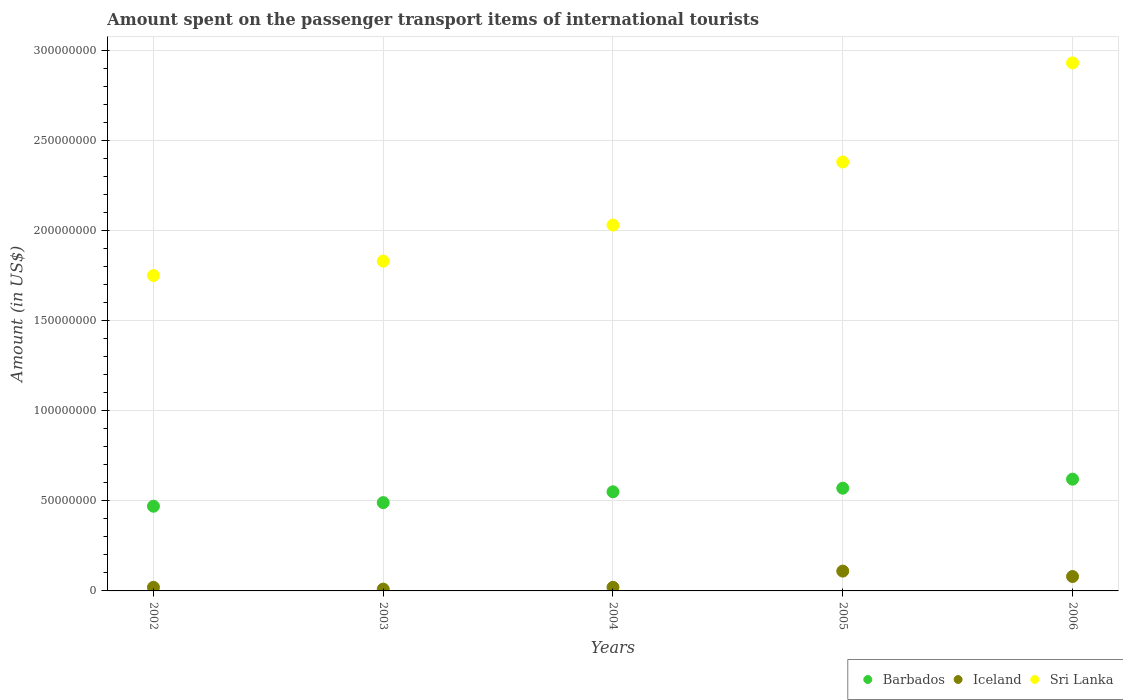How many different coloured dotlines are there?
Give a very brief answer. 3. Is the number of dotlines equal to the number of legend labels?
Your response must be concise. Yes. Across all years, what is the maximum amount spent on the passenger transport items of international tourists in Sri Lanka?
Give a very brief answer. 2.93e+08. Across all years, what is the minimum amount spent on the passenger transport items of international tourists in Barbados?
Keep it short and to the point. 4.70e+07. In which year was the amount spent on the passenger transport items of international tourists in Barbados maximum?
Ensure brevity in your answer.  2006. What is the total amount spent on the passenger transport items of international tourists in Barbados in the graph?
Your response must be concise. 2.70e+08. What is the difference between the amount spent on the passenger transport items of international tourists in Iceland in 2004 and that in 2005?
Give a very brief answer. -9.00e+06. What is the difference between the amount spent on the passenger transport items of international tourists in Sri Lanka in 2004 and the amount spent on the passenger transport items of international tourists in Barbados in 2002?
Your answer should be compact. 1.56e+08. What is the average amount spent on the passenger transport items of international tourists in Iceland per year?
Your response must be concise. 4.80e+06. In the year 2003, what is the difference between the amount spent on the passenger transport items of international tourists in Iceland and amount spent on the passenger transport items of international tourists in Sri Lanka?
Provide a short and direct response. -1.82e+08. In how many years, is the amount spent on the passenger transport items of international tourists in Iceland greater than 220000000 US$?
Provide a succinct answer. 0. What is the ratio of the amount spent on the passenger transport items of international tourists in Sri Lanka in 2002 to that in 2004?
Your response must be concise. 0.86. Is the difference between the amount spent on the passenger transport items of international tourists in Iceland in 2002 and 2006 greater than the difference between the amount spent on the passenger transport items of international tourists in Sri Lanka in 2002 and 2006?
Keep it short and to the point. Yes. What is the difference between the highest and the second highest amount spent on the passenger transport items of international tourists in Iceland?
Offer a very short reply. 3.00e+06. What is the difference between the highest and the lowest amount spent on the passenger transport items of international tourists in Iceland?
Give a very brief answer. 1.00e+07. Is the sum of the amount spent on the passenger transport items of international tourists in Barbados in 2005 and 2006 greater than the maximum amount spent on the passenger transport items of international tourists in Iceland across all years?
Provide a succinct answer. Yes. What is the difference between two consecutive major ticks on the Y-axis?
Provide a short and direct response. 5.00e+07. Does the graph contain any zero values?
Provide a short and direct response. No. Where does the legend appear in the graph?
Offer a very short reply. Bottom right. What is the title of the graph?
Ensure brevity in your answer.  Amount spent on the passenger transport items of international tourists. Does "Philippines" appear as one of the legend labels in the graph?
Give a very brief answer. No. What is the label or title of the Y-axis?
Offer a very short reply. Amount (in US$). What is the Amount (in US$) in Barbados in 2002?
Provide a short and direct response. 4.70e+07. What is the Amount (in US$) of Iceland in 2002?
Your response must be concise. 2.00e+06. What is the Amount (in US$) in Sri Lanka in 2002?
Ensure brevity in your answer.  1.75e+08. What is the Amount (in US$) of Barbados in 2003?
Your answer should be compact. 4.90e+07. What is the Amount (in US$) of Sri Lanka in 2003?
Make the answer very short. 1.83e+08. What is the Amount (in US$) of Barbados in 2004?
Make the answer very short. 5.50e+07. What is the Amount (in US$) of Sri Lanka in 2004?
Make the answer very short. 2.03e+08. What is the Amount (in US$) in Barbados in 2005?
Give a very brief answer. 5.70e+07. What is the Amount (in US$) in Iceland in 2005?
Offer a terse response. 1.10e+07. What is the Amount (in US$) of Sri Lanka in 2005?
Keep it short and to the point. 2.38e+08. What is the Amount (in US$) in Barbados in 2006?
Your answer should be very brief. 6.20e+07. What is the Amount (in US$) in Sri Lanka in 2006?
Provide a short and direct response. 2.93e+08. Across all years, what is the maximum Amount (in US$) of Barbados?
Provide a short and direct response. 6.20e+07. Across all years, what is the maximum Amount (in US$) of Iceland?
Provide a short and direct response. 1.10e+07. Across all years, what is the maximum Amount (in US$) in Sri Lanka?
Offer a terse response. 2.93e+08. Across all years, what is the minimum Amount (in US$) of Barbados?
Offer a very short reply. 4.70e+07. Across all years, what is the minimum Amount (in US$) of Sri Lanka?
Your response must be concise. 1.75e+08. What is the total Amount (in US$) in Barbados in the graph?
Your response must be concise. 2.70e+08. What is the total Amount (in US$) of Iceland in the graph?
Offer a very short reply. 2.40e+07. What is the total Amount (in US$) of Sri Lanka in the graph?
Your response must be concise. 1.09e+09. What is the difference between the Amount (in US$) in Barbados in 2002 and that in 2003?
Provide a succinct answer. -2.00e+06. What is the difference between the Amount (in US$) in Iceland in 2002 and that in 2003?
Your answer should be compact. 1.00e+06. What is the difference between the Amount (in US$) of Sri Lanka in 2002 and that in 2003?
Offer a terse response. -8.00e+06. What is the difference between the Amount (in US$) in Barbados in 2002 and that in 2004?
Your answer should be very brief. -8.00e+06. What is the difference between the Amount (in US$) of Iceland in 2002 and that in 2004?
Your answer should be compact. 0. What is the difference between the Amount (in US$) of Sri Lanka in 2002 and that in 2004?
Your response must be concise. -2.80e+07. What is the difference between the Amount (in US$) of Barbados in 2002 and that in 2005?
Your response must be concise. -1.00e+07. What is the difference between the Amount (in US$) of Iceland in 2002 and that in 2005?
Give a very brief answer. -9.00e+06. What is the difference between the Amount (in US$) in Sri Lanka in 2002 and that in 2005?
Offer a terse response. -6.30e+07. What is the difference between the Amount (in US$) of Barbados in 2002 and that in 2006?
Make the answer very short. -1.50e+07. What is the difference between the Amount (in US$) of Iceland in 2002 and that in 2006?
Your answer should be compact. -6.00e+06. What is the difference between the Amount (in US$) in Sri Lanka in 2002 and that in 2006?
Provide a succinct answer. -1.18e+08. What is the difference between the Amount (in US$) of Barbados in 2003 and that in 2004?
Provide a succinct answer. -6.00e+06. What is the difference between the Amount (in US$) of Sri Lanka in 2003 and that in 2004?
Keep it short and to the point. -2.00e+07. What is the difference between the Amount (in US$) of Barbados in 2003 and that in 2005?
Offer a terse response. -8.00e+06. What is the difference between the Amount (in US$) in Iceland in 2003 and that in 2005?
Keep it short and to the point. -1.00e+07. What is the difference between the Amount (in US$) of Sri Lanka in 2003 and that in 2005?
Make the answer very short. -5.50e+07. What is the difference between the Amount (in US$) of Barbados in 2003 and that in 2006?
Offer a very short reply. -1.30e+07. What is the difference between the Amount (in US$) of Iceland in 2003 and that in 2006?
Make the answer very short. -7.00e+06. What is the difference between the Amount (in US$) in Sri Lanka in 2003 and that in 2006?
Keep it short and to the point. -1.10e+08. What is the difference between the Amount (in US$) of Barbados in 2004 and that in 2005?
Ensure brevity in your answer.  -2.00e+06. What is the difference between the Amount (in US$) of Iceland in 2004 and that in 2005?
Offer a very short reply. -9.00e+06. What is the difference between the Amount (in US$) in Sri Lanka in 2004 and that in 2005?
Offer a very short reply. -3.50e+07. What is the difference between the Amount (in US$) of Barbados in 2004 and that in 2006?
Provide a succinct answer. -7.00e+06. What is the difference between the Amount (in US$) in Iceland in 2004 and that in 2006?
Give a very brief answer. -6.00e+06. What is the difference between the Amount (in US$) in Sri Lanka in 2004 and that in 2006?
Make the answer very short. -9.00e+07. What is the difference between the Amount (in US$) in Barbados in 2005 and that in 2006?
Your answer should be compact. -5.00e+06. What is the difference between the Amount (in US$) in Iceland in 2005 and that in 2006?
Give a very brief answer. 3.00e+06. What is the difference between the Amount (in US$) in Sri Lanka in 2005 and that in 2006?
Your answer should be compact. -5.50e+07. What is the difference between the Amount (in US$) in Barbados in 2002 and the Amount (in US$) in Iceland in 2003?
Offer a very short reply. 4.60e+07. What is the difference between the Amount (in US$) of Barbados in 2002 and the Amount (in US$) of Sri Lanka in 2003?
Your answer should be very brief. -1.36e+08. What is the difference between the Amount (in US$) of Iceland in 2002 and the Amount (in US$) of Sri Lanka in 2003?
Keep it short and to the point. -1.81e+08. What is the difference between the Amount (in US$) in Barbados in 2002 and the Amount (in US$) in Iceland in 2004?
Your answer should be very brief. 4.50e+07. What is the difference between the Amount (in US$) of Barbados in 2002 and the Amount (in US$) of Sri Lanka in 2004?
Offer a very short reply. -1.56e+08. What is the difference between the Amount (in US$) of Iceland in 2002 and the Amount (in US$) of Sri Lanka in 2004?
Your answer should be very brief. -2.01e+08. What is the difference between the Amount (in US$) of Barbados in 2002 and the Amount (in US$) of Iceland in 2005?
Your response must be concise. 3.60e+07. What is the difference between the Amount (in US$) of Barbados in 2002 and the Amount (in US$) of Sri Lanka in 2005?
Give a very brief answer. -1.91e+08. What is the difference between the Amount (in US$) in Iceland in 2002 and the Amount (in US$) in Sri Lanka in 2005?
Provide a short and direct response. -2.36e+08. What is the difference between the Amount (in US$) of Barbados in 2002 and the Amount (in US$) of Iceland in 2006?
Ensure brevity in your answer.  3.90e+07. What is the difference between the Amount (in US$) in Barbados in 2002 and the Amount (in US$) in Sri Lanka in 2006?
Keep it short and to the point. -2.46e+08. What is the difference between the Amount (in US$) in Iceland in 2002 and the Amount (in US$) in Sri Lanka in 2006?
Provide a succinct answer. -2.91e+08. What is the difference between the Amount (in US$) of Barbados in 2003 and the Amount (in US$) of Iceland in 2004?
Offer a very short reply. 4.70e+07. What is the difference between the Amount (in US$) of Barbados in 2003 and the Amount (in US$) of Sri Lanka in 2004?
Offer a very short reply. -1.54e+08. What is the difference between the Amount (in US$) in Iceland in 2003 and the Amount (in US$) in Sri Lanka in 2004?
Keep it short and to the point. -2.02e+08. What is the difference between the Amount (in US$) in Barbados in 2003 and the Amount (in US$) in Iceland in 2005?
Offer a very short reply. 3.80e+07. What is the difference between the Amount (in US$) in Barbados in 2003 and the Amount (in US$) in Sri Lanka in 2005?
Ensure brevity in your answer.  -1.89e+08. What is the difference between the Amount (in US$) in Iceland in 2003 and the Amount (in US$) in Sri Lanka in 2005?
Provide a succinct answer. -2.37e+08. What is the difference between the Amount (in US$) in Barbados in 2003 and the Amount (in US$) in Iceland in 2006?
Give a very brief answer. 4.10e+07. What is the difference between the Amount (in US$) of Barbados in 2003 and the Amount (in US$) of Sri Lanka in 2006?
Offer a very short reply. -2.44e+08. What is the difference between the Amount (in US$) of Iceland in 2003 and the Amount (in US$) of Sri Lanka in 2006?
Ensure brevity in your answer.  -2.92e+08. What is the difference between the Amount (in US$) of Barbados in 2004 and the Amount (in US$) of Iceland in 2005?
Make the answer very short. 4.40e+07. What is the difference between the Amount (in US$) of Barbados in 2004 and the Amount (in US$) of Sri Lanka in 2005?
Offer a terse response. -1.83e+08. What is the difference between the Amount (in US$) of Iceland in 2004 and the Amount (in US$) of Sri Lanka in 2005?
Make the answer very short. -2.36e+08. What is the difference between the Amount (in US$) of Barbados in 2004 and the Amount (in US$) of Iceland in 2006?
Provide a succinct answer. 4.70e+07. What is the difference between the Amount (in US$) in Barbados in 2004 and the Amount (in US$) in Sri Lanka in 2006?
Offer a very short reply. -2.38e+08. What is the difference between the Amount (in US$) of Iceland in 2004 and the Amount (in US$) of Sri Lanka in 2006?
Your response must be concise. -2.91e+08. What is the difference between the Amount (in US$) of Barbados in 2005 and the Amount (in US$) of Iceland in 2006?
Your answer should be compact. 4.90e+07. What is the difference between the Amount (in US$) of Barbados in 2005 and the Amount (in US$) of Sri Lanka in 2006?
Make the answer very short. -2.36e+08. What is the difference between the Amount (in US$) in Iceland in 2005 and the Amount (in US$) in Sri Lanka in 2006?
Offer a very short reply. -2.82e+08. What is the average Amount (in US$) of Barbados per year?
Your response must be concise. 5.40e+07. What is the average Amount (in US$) of Iceland per year?
Your answer should be compact. 4.80e+06. What is the average Amount (in US$) of Sri Lanka per year?
Your response must be concise. 2.18e+08. In the year 2002, what is the difference between the Amount (in US$) in Barbados and Amount (in US$) in Iceland?
Your answer should be very brief. 4.50e+07. In the year 2002, what is the difference between the Amount (in US$) of Barbados and Amount (in US$) of Sri Lanka?
Give a very brief answer. -1.28e+08. In the year 2002, what is the difference between the Amount (in US$) of Iceland and Amount (in US$) of Sri Lanka?
Make the answer very short. -1.73e+08. In the year 2003, what is the difference between the Amount (in US$) in Barbados and Amount (in US$) in Iceland?
Keep it short and to the point. 4.80e+07. In the year 2003, what is the difference between the Amount (in US$) in Barbados and Amount (in US$) in Sri Lanka?
Your response must be concise. -1.34e+08. In the year 2003, what is the difference between the Amount (in US$) in Iceland and Amount (in US$) in Sri Lanka?
Offer a terse response. -1.82e+08. In the year 2004, what is the difference between the Amount (in US$) of Barbados and Amount (in US$) of Iceland?
Your response must be concise. 5.30e+07. In the year 2004, what is the difference between the Amount (in US$) of Barbados and Amount (in US$) of Sri Lanka?
Ensure brevity in your answer.  -1.48e+08. In the year 2004, what is the difference between the Amount (in US$) of Iceland and Amount (in US$) of Sri Lanka?
Offer a terse response. -2.01e+08. In the year 2005, what is the difference between the Amount (in US$) in Barbados and Amount (in US$) in Iceland?
Make the answer very short. 4.60e+07. In the year 2005, what is the difference between the Amount (in US$) of Barbados and Amount (in US$) of Sri Lanka?
Ensure brevity in your answer.  -1.81e+08. In the year 2005, what is the difference between the Amount (in US$) in Iceland and Amount (in US$) in Sri Lanka?
Your response must be concise. -2.27e+08. In the year 2006, what is the difference between the Amount (in US$) of Barbados and Amount (in US$) of Iceland?
Offer a terse response. 5.40e+07. In the year 2006, what is the difference between the Amount (in US$) in Barbados and Amount (in US$) in Sri Lanka?
Your response must be concise. -2.31e+08. In the year 2006, what is the difference between the Amount (in US$) in Iceland and Amount (in US$) in Sri Lanka?
Give a very brief answer. -2.85e+08. What is the ratio of the Amount (in US$) in Barbados in 2002 to that in 2003?
Keep it short and to the point. 0.96. What is the ratio of the Amount (in US$) in Iceland in 2002 to that in 2003?
Your answer should be compact. 2. What is the ratio of the Amount (in US$) of Sri Lanka in 2002 to that in 2003?
Keep it short and to the point. 0.96. What is the ratio of the Amount (in US$) of Barbados in 2002 to that in 2004?
Give a very brief answer. 0.85. What is the ratio of the Amount (in US$) of Iceland in 2002 to that in 2004?
Your answer should be very brief. 1. What is the ratio of the Amount (in US$) in Sri Lanka in 2002 to that in 2004?
Provide a short and direct response. 0.86. What is the ratio of the Amount (in US$) of Barbados in 2002 to that in 2005?
Your response must be concise. 0.82. What is the ratio of the Amount (in US$) in Iceland in 2002 to that in 2005?
Keep it short and to the point. 0.18. What is the ratio of the Amount (in US$) of Sri Lanka in 2002 to that in 2005?
Your response must be concise. 0.74. What is the ratio of the Amount (in US$) of Barbados in 2002 to that in 2006?
Offer a terse response. 0.76. What is the ratio of the Amount (in US$) of Sri Lanka in 2002 to that in 2006?
Your answer should be compact. 0.6. What is the ratio of the Amount (in US$) in Barbados in 2003 to that in 2004?
Provide a succinct answer. 0.89. What is the ratio of the Amount (in US$) in Sri Lanka in 2003 to that in 2004?
Offer a terse response. 0.9. What is the ratio of the Amount (in US$) of Barbados in 2003 to that in 2005?
Give a very brief answer. 0.86. What is the ratio of the Amount (in US$) in Iceland in 2003 to that in 2005?
Your answer should be very brief. 0.09. What is the ratio of the Amount (in US$) of Sri Lanka in 2003 to that in 2005?
Your answer should be compact. 0.77. What is the ratio of the Amount (in US$) in Barbados in 2003 to that in 2006?
Provide a succinct answer. 0.79. What is the ratio of the Amount (in US$) in Iceland in 2003 to that in 2006?
Keep it short and to the point. 0.12. What is the ratio of the Amount (in US$) of Sri Lanka in 2003 to that in 2006?
Your answer should be compact. 0.62. What is the ratio of the Amount (in US$) in Barbados in 2004 to that in 2005?
Provide a succinct answer. 0.96. What is the ratio of the Amount (in US$) of Iceland in 2004 to that in 2005?
Offer a very short reply. 0.18. What is the ratio of the Amount (in US$) of Sri Lanka in 2004 to that in 2005?
Provide a short and direct response. 0.85. What is the ratio of the Amount (in US$) in Barbados in 2004 to that in 2006?
Your answer should be very brief. 0.89. What is the ratio of the Amount (in US$) in Sri Lanka in 2004 to that in 2006?
Offer a terse response. 0.69. What is the ratio of the Amount (in US$) of Barbados in 2005 to that in 2006?
Offer a terse response. 0.92. What is the ratio of the Amount (in US$) in Iceland in 2005 to that in 2006?
Give a very brief answer. 1.38. What is the ratio of the Amount (in US$) of Sri Lanka in 2005 to that in 2006?
Offer a very short reply. 0.81. What is the difference between the highest and the second highest Amount (in US$) of Iceland?
Provide a succinct answer. 3.00e+06. What is the difference between the highest and the second highest Amount (in US$) of Sri Lanka?
Ensure brevity in your answer.  5.50e+07. What is the difference between the highest and the lowest Amount (in US$) in Barbados?
Your response must be concise. 1.50e+07. What is the difference between the highest and the lowest Amount (in US$) in Iceland?
Ensure brevity in your answer.  1.00e+07. What is the difference between the highest and the lowest Amount (in US$) in Sri Lanka?
Ensure brevity in your answer.  1.18e+08. 